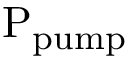<formula> <loc_0><loc_0><loc_500><loc_500>P _ { p u m p }</formula> 